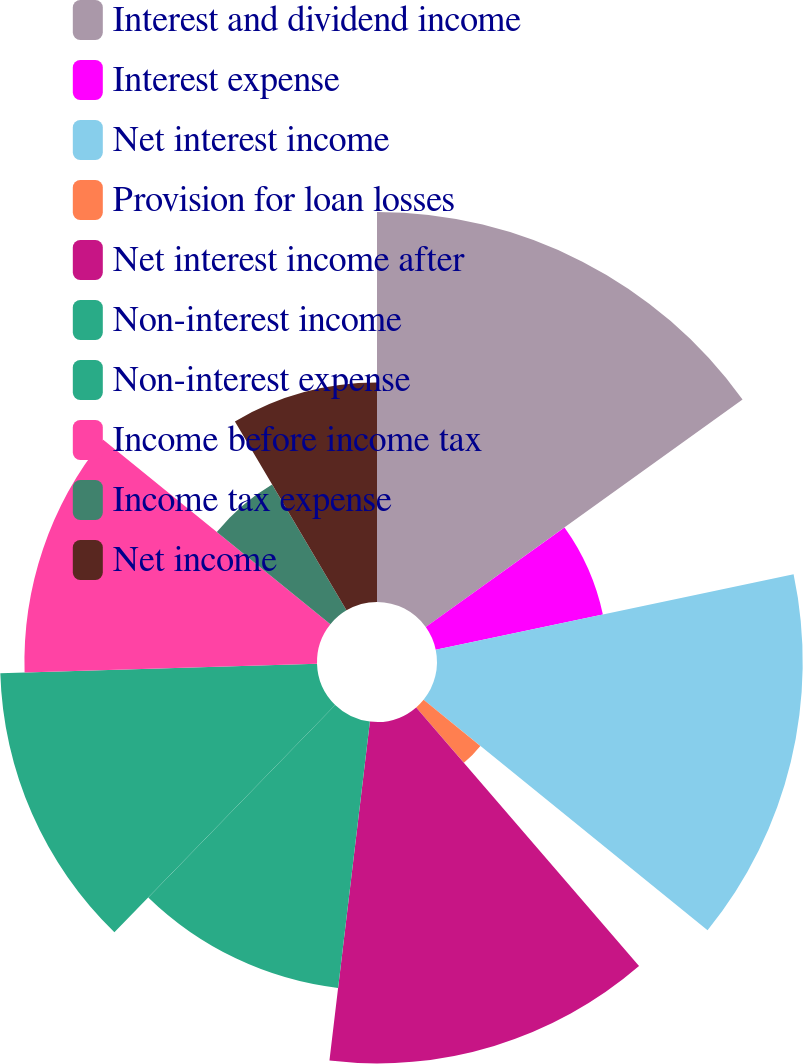Convert chart. <chart><loc_0><loc_0><loc_500><loc_500><pie_chart><fcel>Interest and dividend income<fcel>Interest expense<fcel>Net interest income<fcel>Provision for loan losses<fcel>Net interest income after<fcel>Non-interest income<fcel>Non-interest expense<fcel>Income before income tax<fcel>Income tax expense<fcel>Net income<nl><fcel>15.09%<fcel>6.61%<fcel>14.15%<fcel>2.83%<fcel>13.21%<fcel>10.38%<fcel>12.26%<fcel>11.32%<fcel>5.66%<fcel>8.49%<nl></chart> 